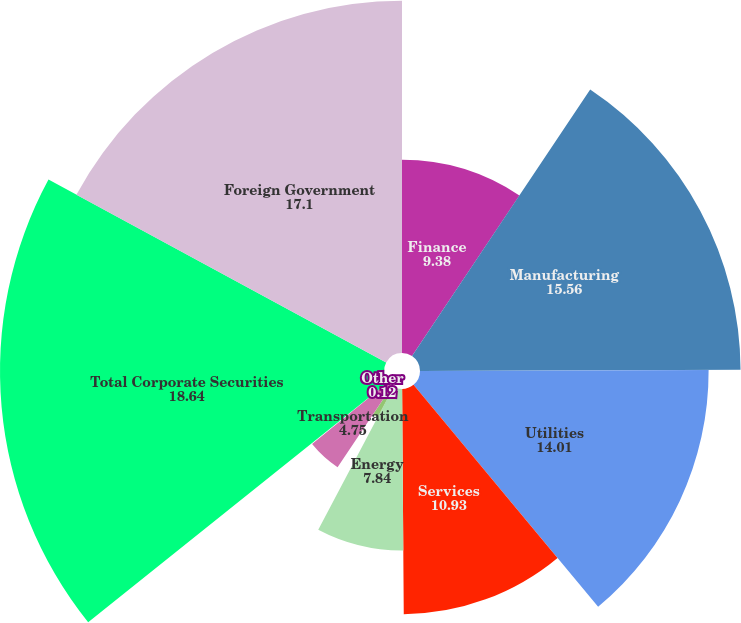Convert chart to OTSL. <chart><loc_0><loc_0><loc_500><loc_500><pie_chart><fcel>Finance<fcel>Manufacturing<fcel>Utilities<fcel>Services<fcel>Energy<fcel>Retail and Wholesale<fcel>Transportation<fcel>Other<fcel>Total Corporate Securities<fcel>Foreign Government<nl><fcel>9.38%<fcel>15.56%<fcel>14.01%<fcel>10.93%<fcel>7.84%<fcel>1.66%<fcel>4.75%<fcel>0.12%<fcel>18.64%<fcel>17.1%<nl></chart> 